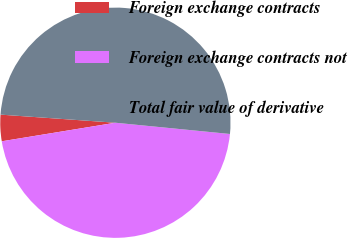Convert chart to OTSL. <chart><loc_0><loc_0><loc_500><loc_500><pie_chart><fcel>Foreign exchange contracts<fcel>Foreign exchange contracts not<fcel>Total fair value of derivative<nl><fcel>3.7%<fcel>45.86%<fcel>50.44%<nl></chart> 